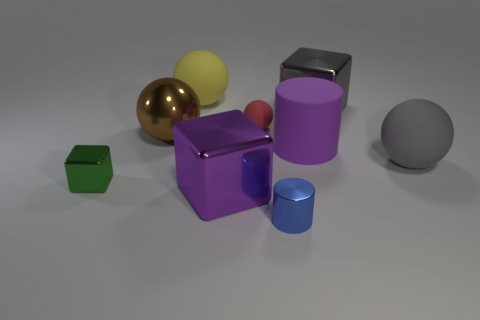What is the material of the red sphere that is the same size as the blue thing?
Your answer should be compact. Rubber. How many other objects are there of the same material as the gray sphere?
Keep it short and to the point. 3. Does the big gray rubber object on the right side of the tiny green metallic block have the same shape as the gray thing that is behind the small red rubber thing?
Make the answer very short. No. The cylinder that is in front of the big matte thing to the right of the cube to the right of the blue cylinder is what color?
Offer a very short reply. Blue. What number of other things are the same color as the small sphere?
Provide a short and direct response. 0. Is the number of matte things less than the number of large yellow objects?
Your answer should be very brief. No. What color is the metal object that is to the right of the tiny red sphere and behind the blue object?
Provide a short and direct response. Gray. There is another tiny object that is the same shape as the purple shiny thing; what is its material?
Ensure brevity in your answer.  Metal. Are there more cyan metallic objects than small spheres?
Make the answer very short. No. How big is the metallic cube that is both in front of the large matte cylinder and behind the purple metal block?
Make the answer very short. Small. 